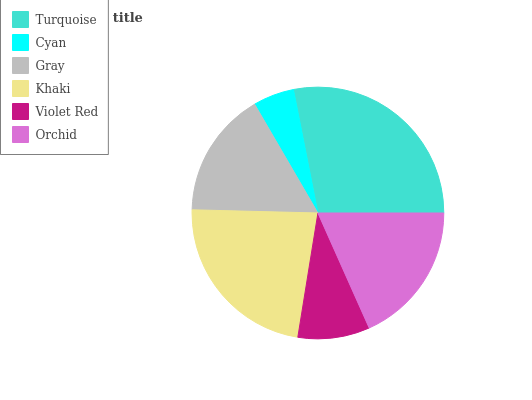Is Cyan the minimum?
Answer yes or no. Yes. Is Turquoise the maximum?
Answer yes or no. Yes. Is Gray the minimum?
Answer yes or no. No. Is Gray the maximum?
Answer yes or no. No. Is Gray greater than Cyan?
Answer yes or no. Yes. Is Cyan less than Gray?
Answer yes or no. Yes. Is Cyan greater than Gray?
Answer yes or no. No. Is Gray less than Cyan?
Answer yes or no. No. Is Orchid the high median?
Answer yes or no. Yes. Is Gray the low median?
Answer yes or no. Yes. Is Khaki the high median?
Answer yes or no. No. Is Violet Red the low median?
Answer yes or no. No. 